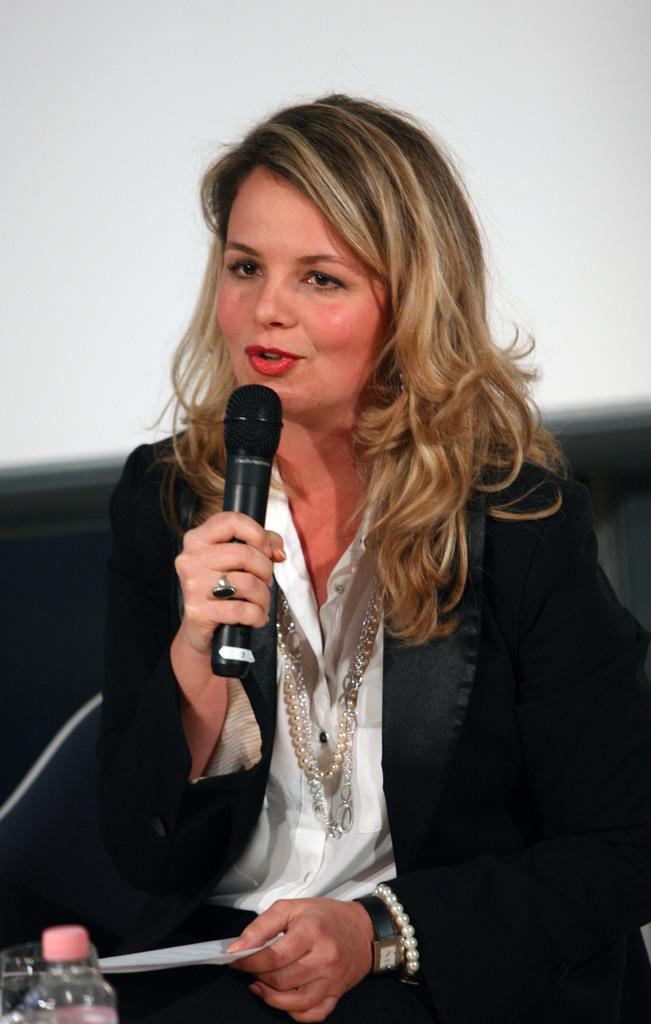Who is present in the image? There is a woman in the image. What is the woman doing in the image? The woman is sitting on a couch and holding a microphone in her hand. What else can be seen in the image besides the woman? There is a paper and a bottle in the image. What type of pies can be seen on the table in the image? There is no table or pies present in the image. 